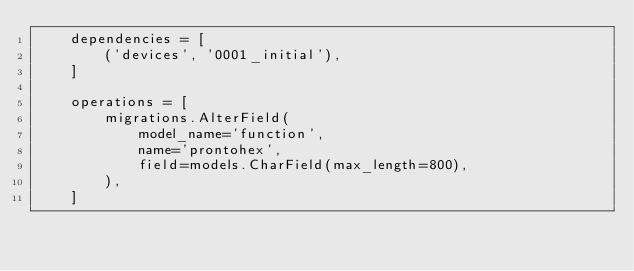Convert code to text. <code><loc_0><loc_0><loc_500><loc_500><_Python_>    dependencies = [
        ('devices', '0001_initial'),
    ]

    operations = [
        migrations.AlterField(
            model_name='function',
            name='prontohex',
            field=models.CharField(max_length=800),
        ),
    ]
</code> 